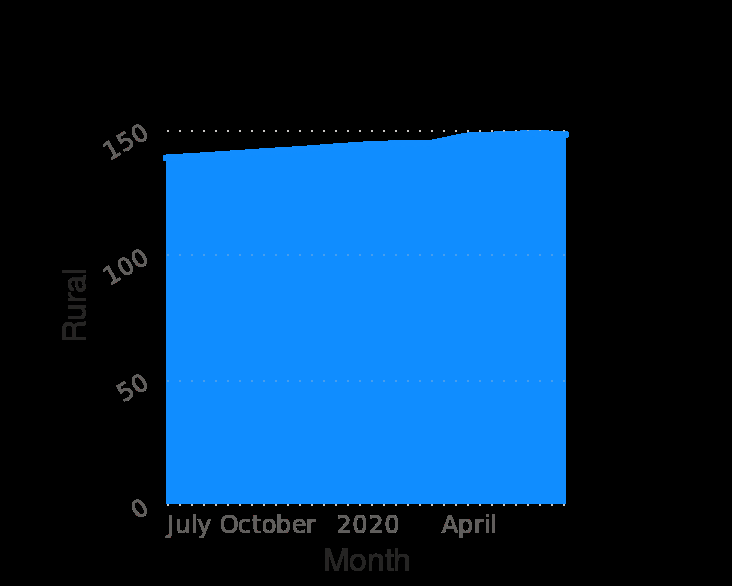<image>
please describe the details of the chart Here a is a area diagram named Consumer Price Index of cereal and its products across urban and rural India from July 2019 to July 2020. The x-axis plots Month while the y-axis plots Rural. What is the current Price Index in the rural areas of India? The current Price Index in the rural areas of India is around 150. Has the Price Index in the rural areas of India significantly increased over the one year period? No, the Price Index in the rural areas of India has only risen marginally over the one year period. What does the area diagram illustrate? The area diagram illustrates the Consumer Price Index of cereal and its products across urban and rural India. What is the title/name of the area diagram? The area diagram is named "Consumer Price Index of cereal and its products across urban and rural India from July 2019 to July 2020." 